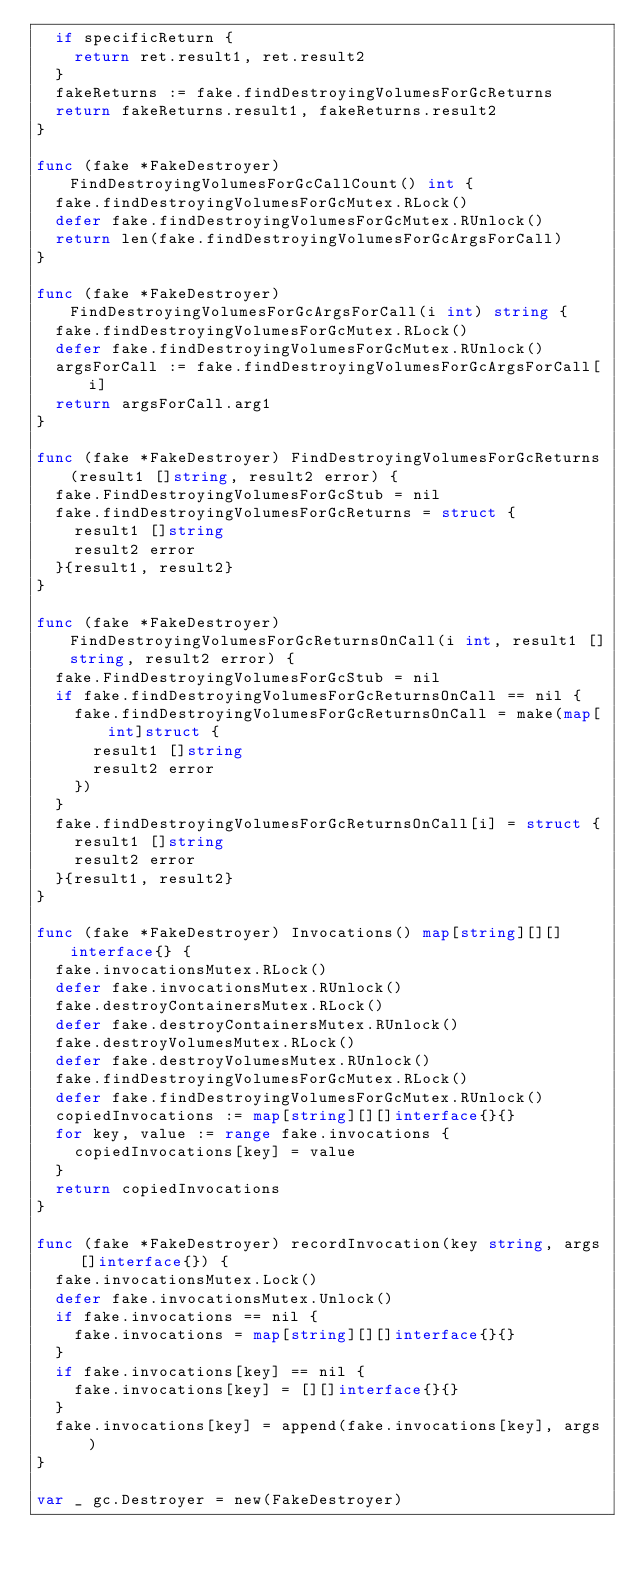Convert code to text. <code><loc_0><loc_0><loc_500><loc_500><_Go_>	if specificReturn {
		return ret.result1, ret.result2
	}
	fakeReturns := fake.findDestroyingVolumesForGcReturns
	return fakeReturns.result1, fakeReturns.result2
}

func (fake *FakeDestroyer) FindDestroyingVolumesForGcCallCount() int {
	fake.findDestroyingVolumesForGcMutex.RLock()
	defer fake.findDestroyingVolumesForGcMutex.RUnlock()
	return len(fake.findDestroyingVolumesForGcArgsForCall)
}

func (fake *FakeDestroyer) FindDestroyingVolumesForGcArgsForCall(i int) string {
	fake.findDestroyingVolumesForGcMutex.RLock()
	defer fake.findDestroyingVolumesForGcMutex.RUnlock()
	argsForCall := fake.findDestroyingVolumesForGcArgsForCall[i]
	return argsForCall.arg1
}

func (fake *FakeDestroyer) FindDestroyingVolumesForGcReturns(result1 []string, result2 error) {
	fake.FindDestroyingVolumesForGcStub = nil
	fake.findDestroyingVolumesForGcReturns = struct {
		result1 []string
		result2 error
	}{result1, result2}
}

func (fake *FakeDestroyer) FindDestroyingVolumesForGcReturnsOnCall(i int, result1 []string, result2 error) {
	fake.FindDestroyingVolumesForGcStub = nil
	if fake.findDestroyingVolumesForGcReturnsOnCall == nil {
		fake.findDestroyingVolumesForGcReturnsOnCall = make(map[int]struct {
			result1 []string
			result2 error
		})
	}
	fake.findDestroyingVolumesForGcReturnsOnCall[i] = struct {
		result1 []string
		result2 error
	}{result1, result2}
}

func (fake *FakeDestroyer) Invocations() map[string][][]interface{} {
	fake.invocationsMutex.RLock()
	defer fake.invocationsMutex.RUnlock()
	fake.destroyContainersMutex.RLock()
	defer fake.destroyContainersMutex.RUnlock()
	fake.destroyVolumesMutex.RLock()
	defer fake.destroyVolumesMutex.RUnlock()
	fake.findDestroyingVolumesForGcMutex.RLock()
	defer fake.findDestroyingVolumesForGcMutex.RUnlock()
	copiedInvocations := map[string][][]interface{}{}
	for key, value := range fake.invocations {
		copiedInvocations[key] = value
	}
	return copiedInvocations
}

func (fake *FakeDestroyer) recordInvocation(key string, args []interface{}) {
	fake.invocationsMutex.Lock()
	defer fake.invocationsMutex.Unlock()
	if fake.invocations == nil {
		fake.invocations = map[string][][]interface{}{}
	}
	if fake.invocations[key] == nil {
		fake.invocations[key] = [][]interface{}{}
	}
	fake.invocations[key] = append(fake.invocations[key], args)
}

var _ gc.Destroyer = new(FakeDestroyer)
</code> 